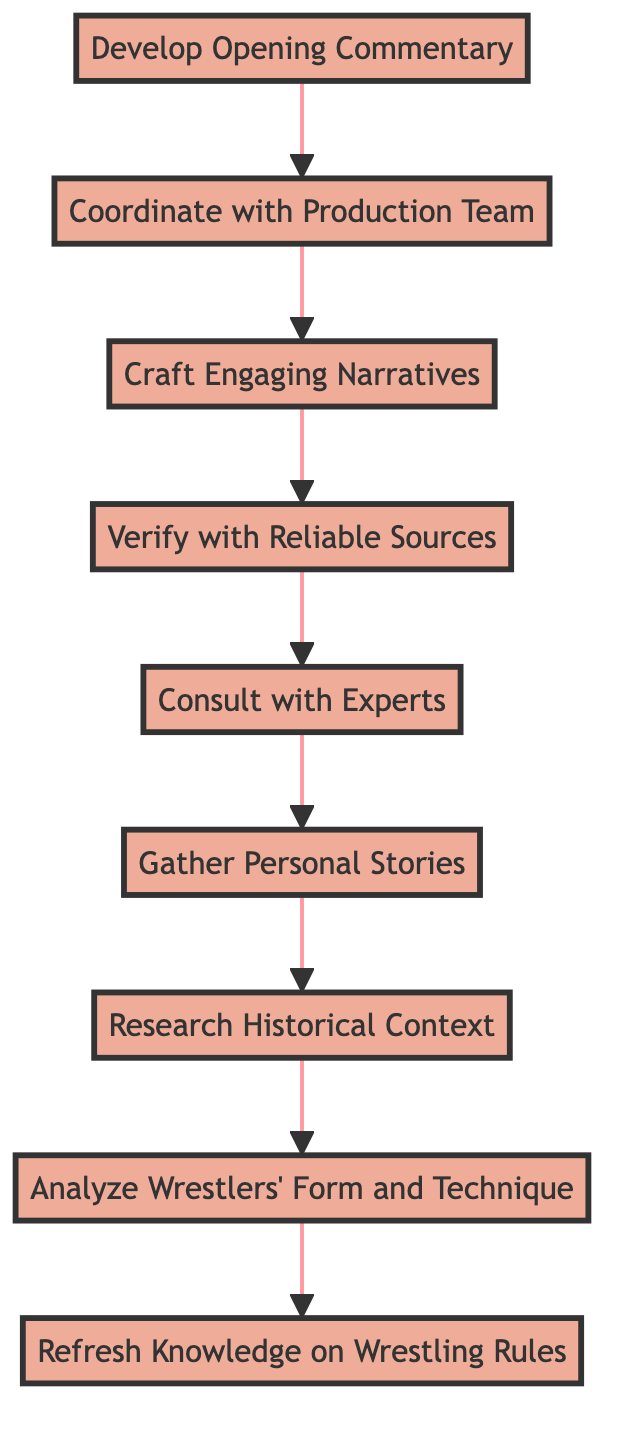What is the first step in preparing pre-match commentaries? The first step is "Develop Opening Commentary," which is at the bottom of the flow chart and indicates the starting point for the preparation process.
Answer: Develop Opening Commentary How many total nodes are in the diagram? Counting all individual steps listed in the diagram from top to bottom, there are nine nodes.
Answer: 9 What follows after "Gather Personal Stories"? After "Gather Personal Stories," the next step is "Research Historical Context," which describes the need to look into the match's significance.
Answer: Research Historical Context Which step involves verifying information? The step that involves verifying information is "Verify with Reliable Sources," which indicates the process of ensuring that the collected data is accurate.
Answer: Verify with Reliable Sources What is the last step before developing the opening commentary? The last step before "Develop Opening Commentary" is "Coordinate with Production Team," which highlights the need to sync with the production team on key points.
Answer: Coordinate with Production Team What common theme connects "Consult with Experts" and "Gather Personal Stories"? Both steps are focused on collecting insights and narratives, one through expert opinions and the other through personal anecdotes about wrestlers.
Answer: Collecting insights and narratives Which step is at the top of the flow chart? The top step, indicating the culmination of the preparation process, is "Refresh Knowledge on Wrestling Rules."
Answer: Refresh Knowledge on Wrestling Rules What relationship exists between "Craft Engaging Narratives" and "Verify with Reliable Sources"? "Craft Engaging Narratives" comes after "Verify with Reliable Sources," meaning narratives are created based on verified, trustworthy information.
Answer: Craft Engaging Narratives follows Verify with Reliable Sources What is the purpose of the "Analyze Wrestlers' Form and Technique" step? The purpose of this step is to study the recent performances, strengths, weaknesses, and techniques of the wrestlers, which informs the commentary.
Answer: Study recent performances and techniques of wrestlers 